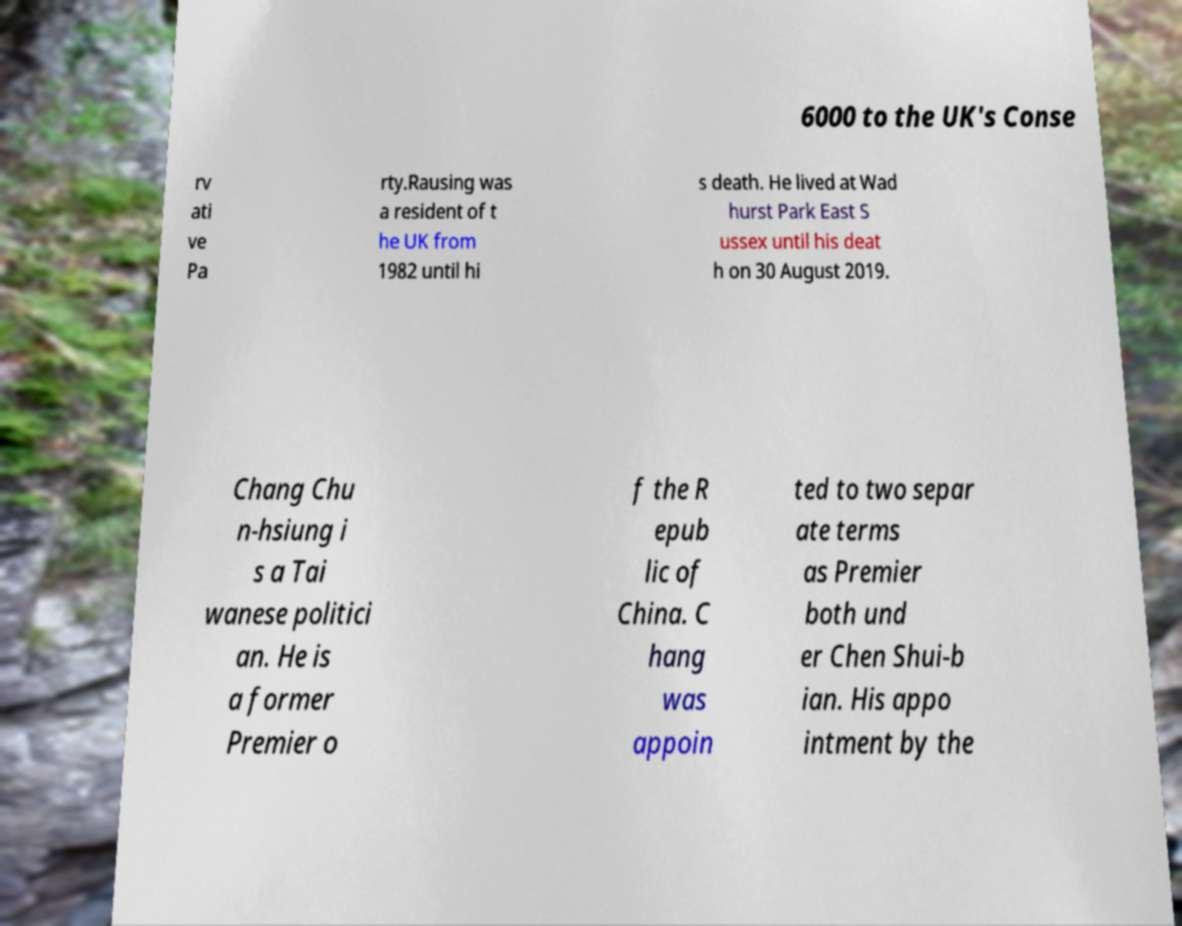I need the written content from this picture converted into text. Can you do that? 6000 to the UK's Conse rv ati ve Pa rty.Rausing was a resident of t he UK from 1982 until hi s death. He lived at Wad hurst Park East S ussex until his deat h on 30 August 2019. Chang Chu n-hsiung i s a Tai wanese politici an. He is a former Premier o f the R epub lic of China. C hang was appoin ted to two separ ate terms as Premier both und er Chen Shui-b ian. His appo intment by the 